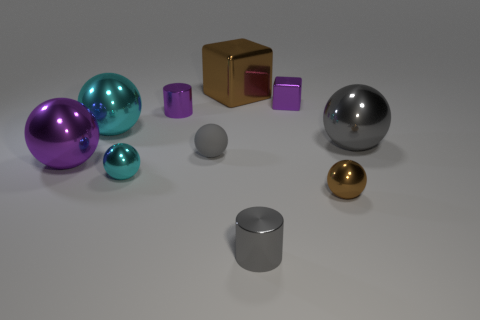Subtract all purple balls. How many balls are left? 5 Subtract all cyan spheres. How many spheres are left? 4 Subtract all yellow spheres. Subtract all green cylinders. How many spheres are left? 6 Subtract all cylinders. How many objects are left? 8 Add 4 large blocks. How many large blocks are left? 5 Add 4 balls. How many balls exist? 10 Subtract 0 cyan cubes. How many objects are left? 10 Subtract all purple shiny spheres. Subtract all cyan balls. How many objects are left? 7 